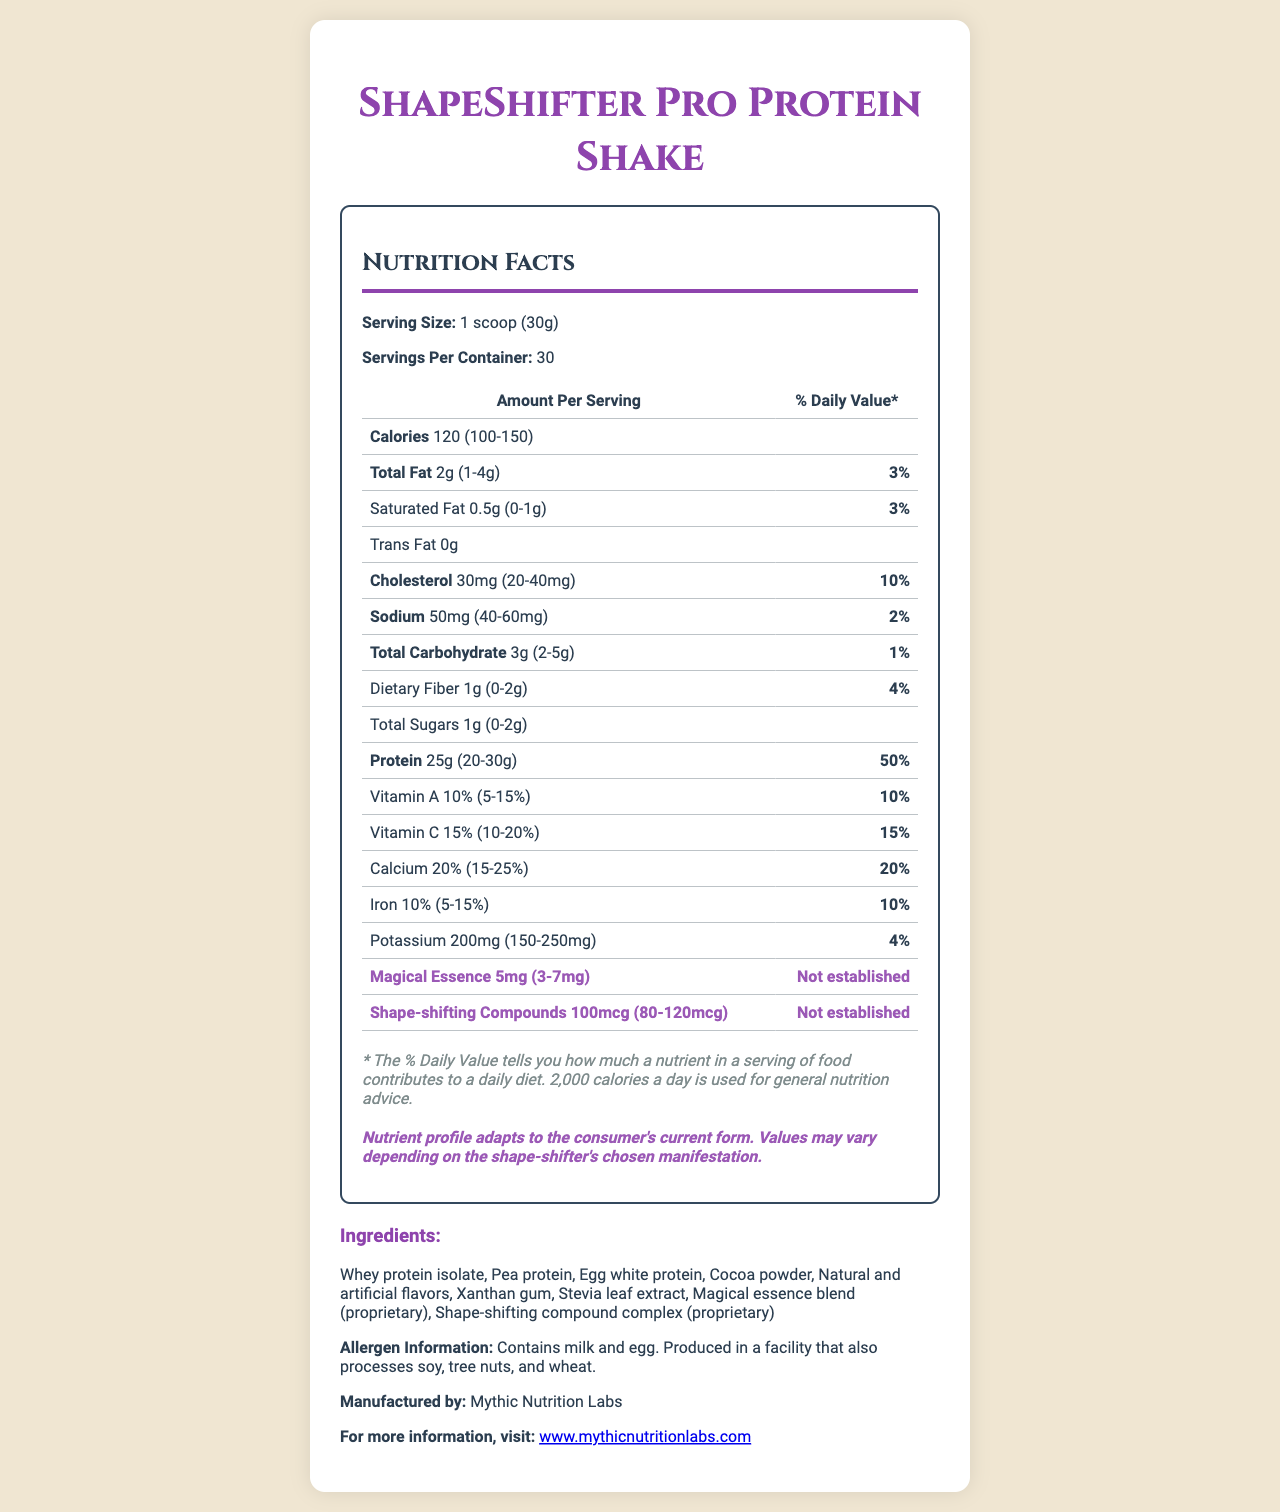how many servings per container are there? The document states "Servings Per Container: 30".
Answer: 30 what is the base amount of calories per serving? The document states "Calories 120".
Answer: 120 what is the base amount of protein per serving? The document states "Protein 25g".
Answer: 25g what ingredient is used as a sweetener in ShapeShifter Pro Protein Shake? The ingredient list includes "Stevia leaf extract".
Answer: Stevia leaf extract what is the daily value percentage for calcium? The document shows "Calcium 20%".
Answer: 20% which nutrient has the highest range in base value? A. Protein B. Total Fat C. Total Carbohydrate Protein has a range of 20-30g, which covers a 10g difference, the highest variation among the listed nutrients.
Answer: A which component has an unestablished daily value? A. Potassium B. Vitamin A C. Magical Essence The document indicates that "Magical Essence" has a daily value of "Not established".
Answer: C does the ShapeShifter Pro Protein Shake contain any trans fats? The document lists "Trans Fat 0g".
Answer: No can the daily amount of magical essence exceed 7mg? The document states the range for magical essence is "3-7mg".
Answer: No what potential allergens are mentioned? The document contains "Allergen Information: Contains milk and egg".
Answer: Milk and egg describe the overall content and purpose of the document The document is designed to inform consumers about the nutritional profile of the ShapeShifter Pro Protein Shake. Highlighting its adaptable nutrient profile for shape-shifters, it includes typical nutritional information and special components relevant to its fantasy nature.
Answer: This document is a Nutrition Facts label for ShapeShifter Pro Protein Shake. It provides detailed information on serving size, calories, macronutrient and micronutrient levels, and ingredients. Special components unique to shape-shifters, such as magical essence and shape-shifting compounds, are also highlighted. The label includes allergen information and a unique disclaimer regarding adaptive nutrient values. It is published by Mythic Nutrition Labs along with a website for further information. what is the exact amount of sugars in a serving? Although the base value and range for sugars are provided, the exact amount is not explicitly defined by a single value in the document.
Answer: Not enough information 